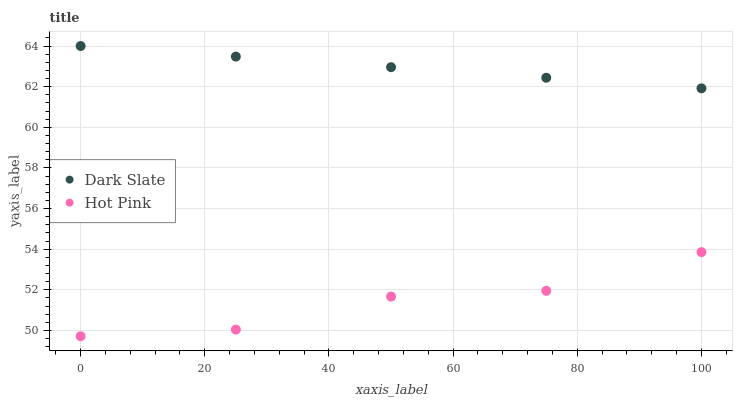Does Hot Pink have the minimum area under the curve?
Answer yes or no. Yes. Does Dark Slate have the maximum area under the curve?
Answer yes or no. Yes. Does Hot Pink have the maximum area under the curve?
Answer yes or no. No. Is Dark Slate the smoothest?
Answer yes or no. Yes. Is Hot Pink the roughest?
Answer yes or no. Yes. Is Hot Pink the smoothest?
Answer yes or no. No. Does Hot Pink have the lowest value?
Answer yes or no. Yes. Does Dark Slate have the highest value?
Answer yes or no. Yes. Does Hot Pink have the highest value?
Answer yes or no. No. Is Hot Pink less than Dark Slate?
Answer yes or no. Yes. Is Dark Slate greater than Hot Pink?
Answer yes or no. Yes. Does Hot Pink intersect Dark Slate?
Answer yes or no. No. 